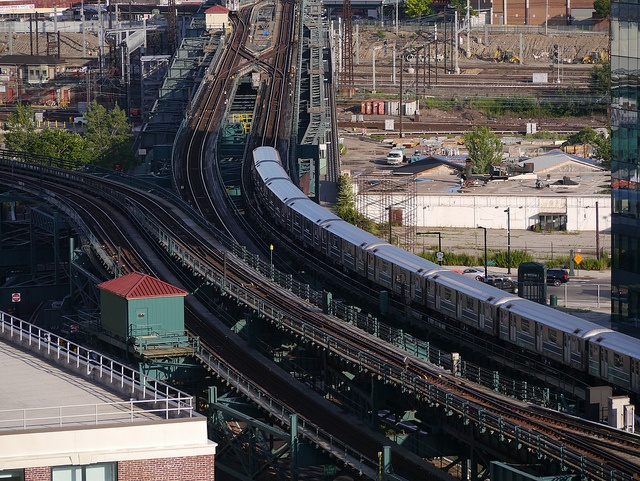Describe the objects in this image and their specific colors. I can see train in beige, black, gray, and darkgray tones, car in beige, black, and gray tones, truck in beige, black, gray, and darkgray tones, truck in beige, black, and gray tones, and car in beige, darkgray, gray, and black tones in this image. 